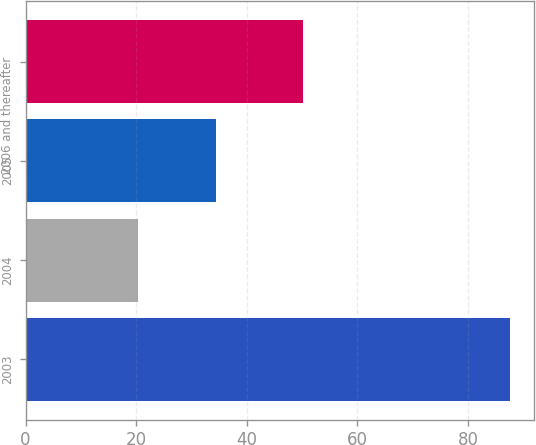Convert chart to OTSL. <chart><loc_0><loc_0><loc_500><loc_500><bar_chart><fcel>2003<fcel>2004<fcel>2005<fcel>2006 and thereafter<nl><fcel>87.6<fcel>20.4<fcel>34.4<fcel>50.1<nl></chart> 